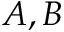Convert formula to latex. <formula><loc_0><loc_0><loc_500><loc_500>A , B</formula> 